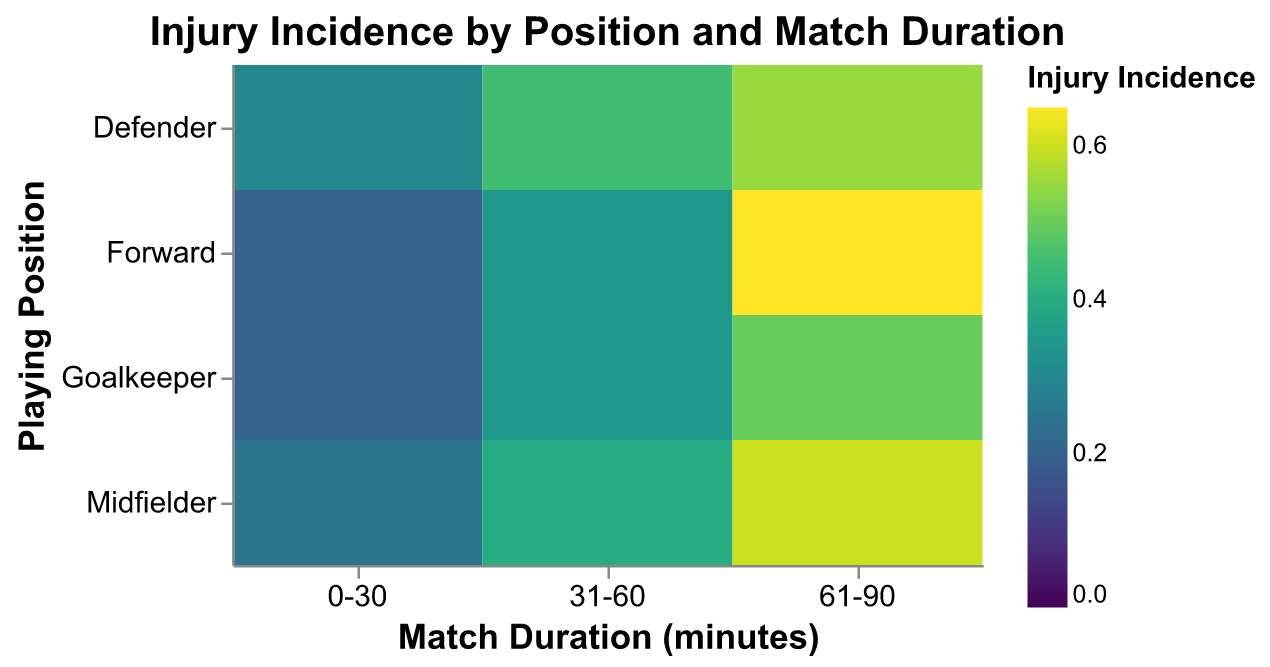What is the injury incidence for goalkeepers in the 61-90 minute range? To find the injury incidence for goalkeepers in the 61-90 minute range, look at the cell where the "Goalkeeper" row intersects with the "61-90" column. The value in that cell is the injury incidence.
Answer: 0.50 Which position has the highest injury incidence in the 0-30 minute range? Scan the "0-30" column to find the highest incidence value and note the corresponding position in the row. The highest value in the "0-30" column is 0.30, which corresponds to the "Defender" position.
Answer: Defender What is the overall trend in injury incidence as match duration increases for midfielders? Evaluate the values in the "Midfielder" row across different match duration ranges ("0-30", "31-60", "61-90"). The values are 0.25, 0.40, and 0.60, showing an increasing trend as the match duration increases.
Answer: Increasing Compare the injury incidence of defenders and forwards in the 61-90 minute range. Which is higher? Identify the values in the "61-90" column for "Defender" and "Forward" rows. The incidence for defenders is 0.55 and for forwards is 0.65. Comparing these values, 0.65 (forwards) is higher.
Answer: Forwards What is the range of injury incidence values presented in the heatmap? Look at the color legend and the values in the heatmap. The lowest value is 0.20 and the highest value is 0.65.
Answer: 0.20 to 0.65 How does the injury incidence of goalkeepers in the 31-60 minute range compare to midfielders in the same range? Identify the injury incidence values for "Goalkeeper" and "Midfielder" in the "31-60" column. For goalkeepers, it's 0.35, and for midfielders, it's 0.40. Comparing these values, midfielders have a higher incidence.
Answer: Midfielders have a higher incidence Which position has the lowest injury incidence in the entire heatmap? Scan through all the cells to find the minimum value. The lowest value is 0.20, which appears twice: for goalkeepers and forwards in the "0-30" minute range.
Answer: Goalkeeper and Forward What can be inferred about the injury risk for players who play more than 60 minutes across all positions? Analyze the values in the "61-90" column for all positions. The injury incidences are notably higher compared to the shorter durations—Goalkeeper (0.50), Defender (0.55), Midfielder (0.60), and Forward (0.65). This suggests that playing more than 60 minutes increases injury risk across all positions.
Answer: Increased risk for all positions What is the difference in injury incidence between defenders and midfielders in the 31-60 minute range? Find the values for defenders and midfielders in the "31-60" column. Defender has 0.45, and midfielder has 0.40. The difference is calculated as 0.45 - 0.40.
Answer: 0.05 